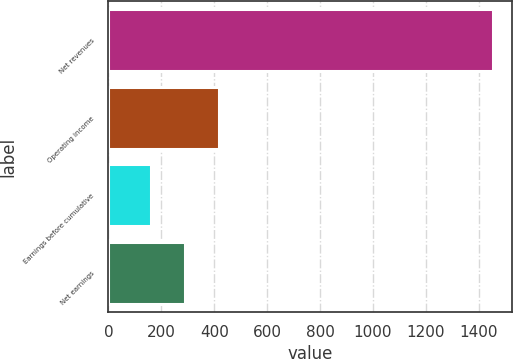Convert chart. <chart><loc_0><loc_0><loc_500><loc_500><bar_chart><fcel>Net revenues<fcel>Operating income<fcel>Earnings before cumulative<fcel>Net earnings<nl><fcel>1452.9<fcel>418.18<fcel>159.5<fcel>288.84<nl></chart> 